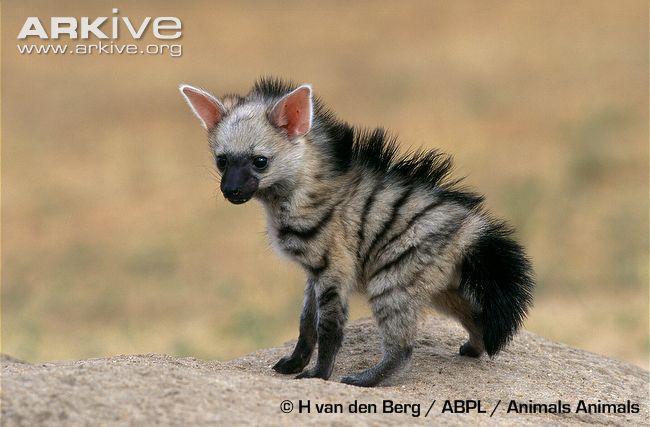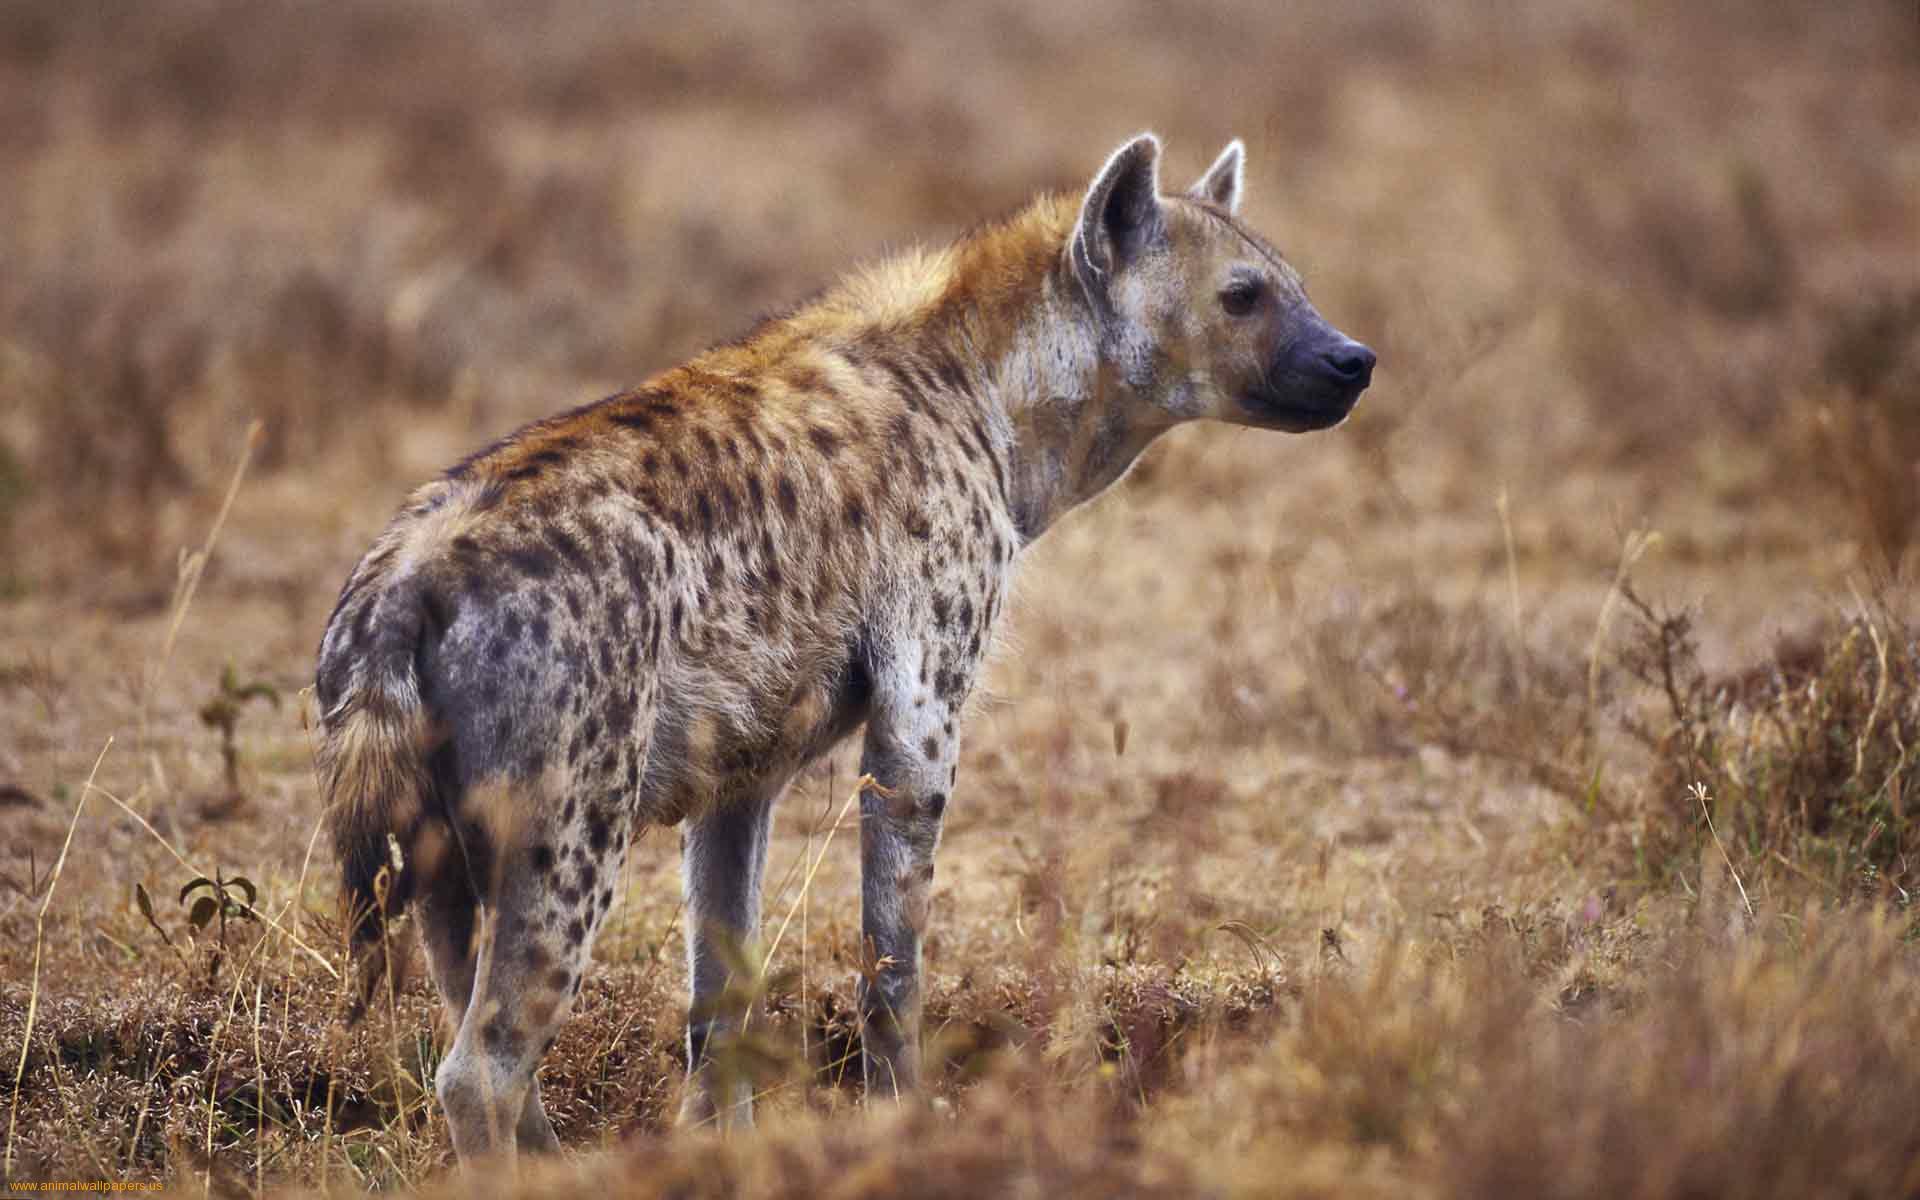The first image is the image on the left, the second image is the image on the right. Analyze the images presented: Is the assertion "One image contains at a least two hyenas." valid? Answer yes or no. No. 